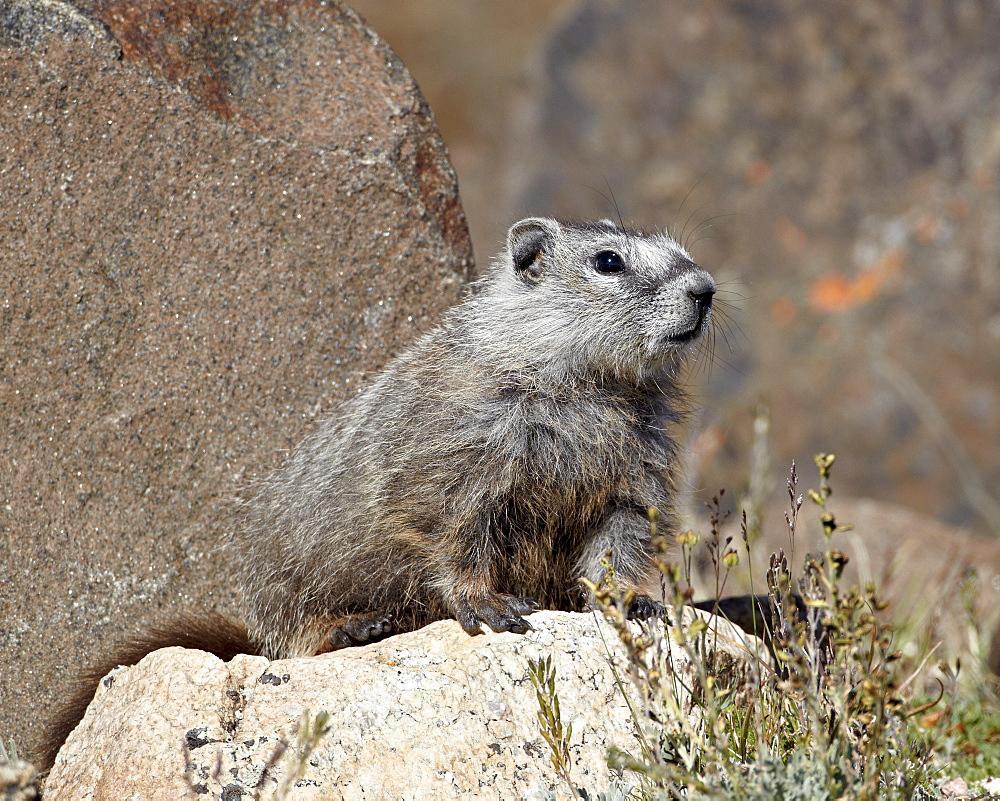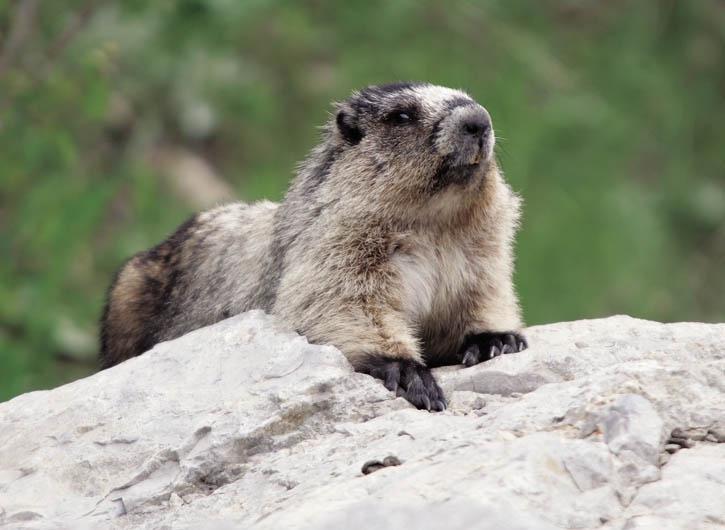The first image is the image on the left, the second image is the image on the right. Examine the images to the left and right. Is the description "There is signal tan and brown animal sitting on a rock looking left." accurate? Answer yes or no. No. The first image is the image on the left, the second image is the image on the right. For the images shown, is this caption "Right image shows a rightward-facing marmot perched on a rock with its tail visible." true? Answer yes or no. No. The first image is the image on the left, the second image is the image on the right. For the images displayed, is the sentence "There are only two animals, and they are facing opposite directions." factually correct? Answer yes or no. No. The first image is the image on the left, the second image is the image on the right. Examine the images to the left and right. Is the description "At least one of the animals is standing up on its hind legs." accurate? Answer yes or no. No. 